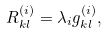<formula> <loc_0><loc_0><loc_500><loc_500>R ^ { ( i ) } _ { k l } = \lambda _ { i } g ^ { ( i ) } _ { k l } ,</formula> 